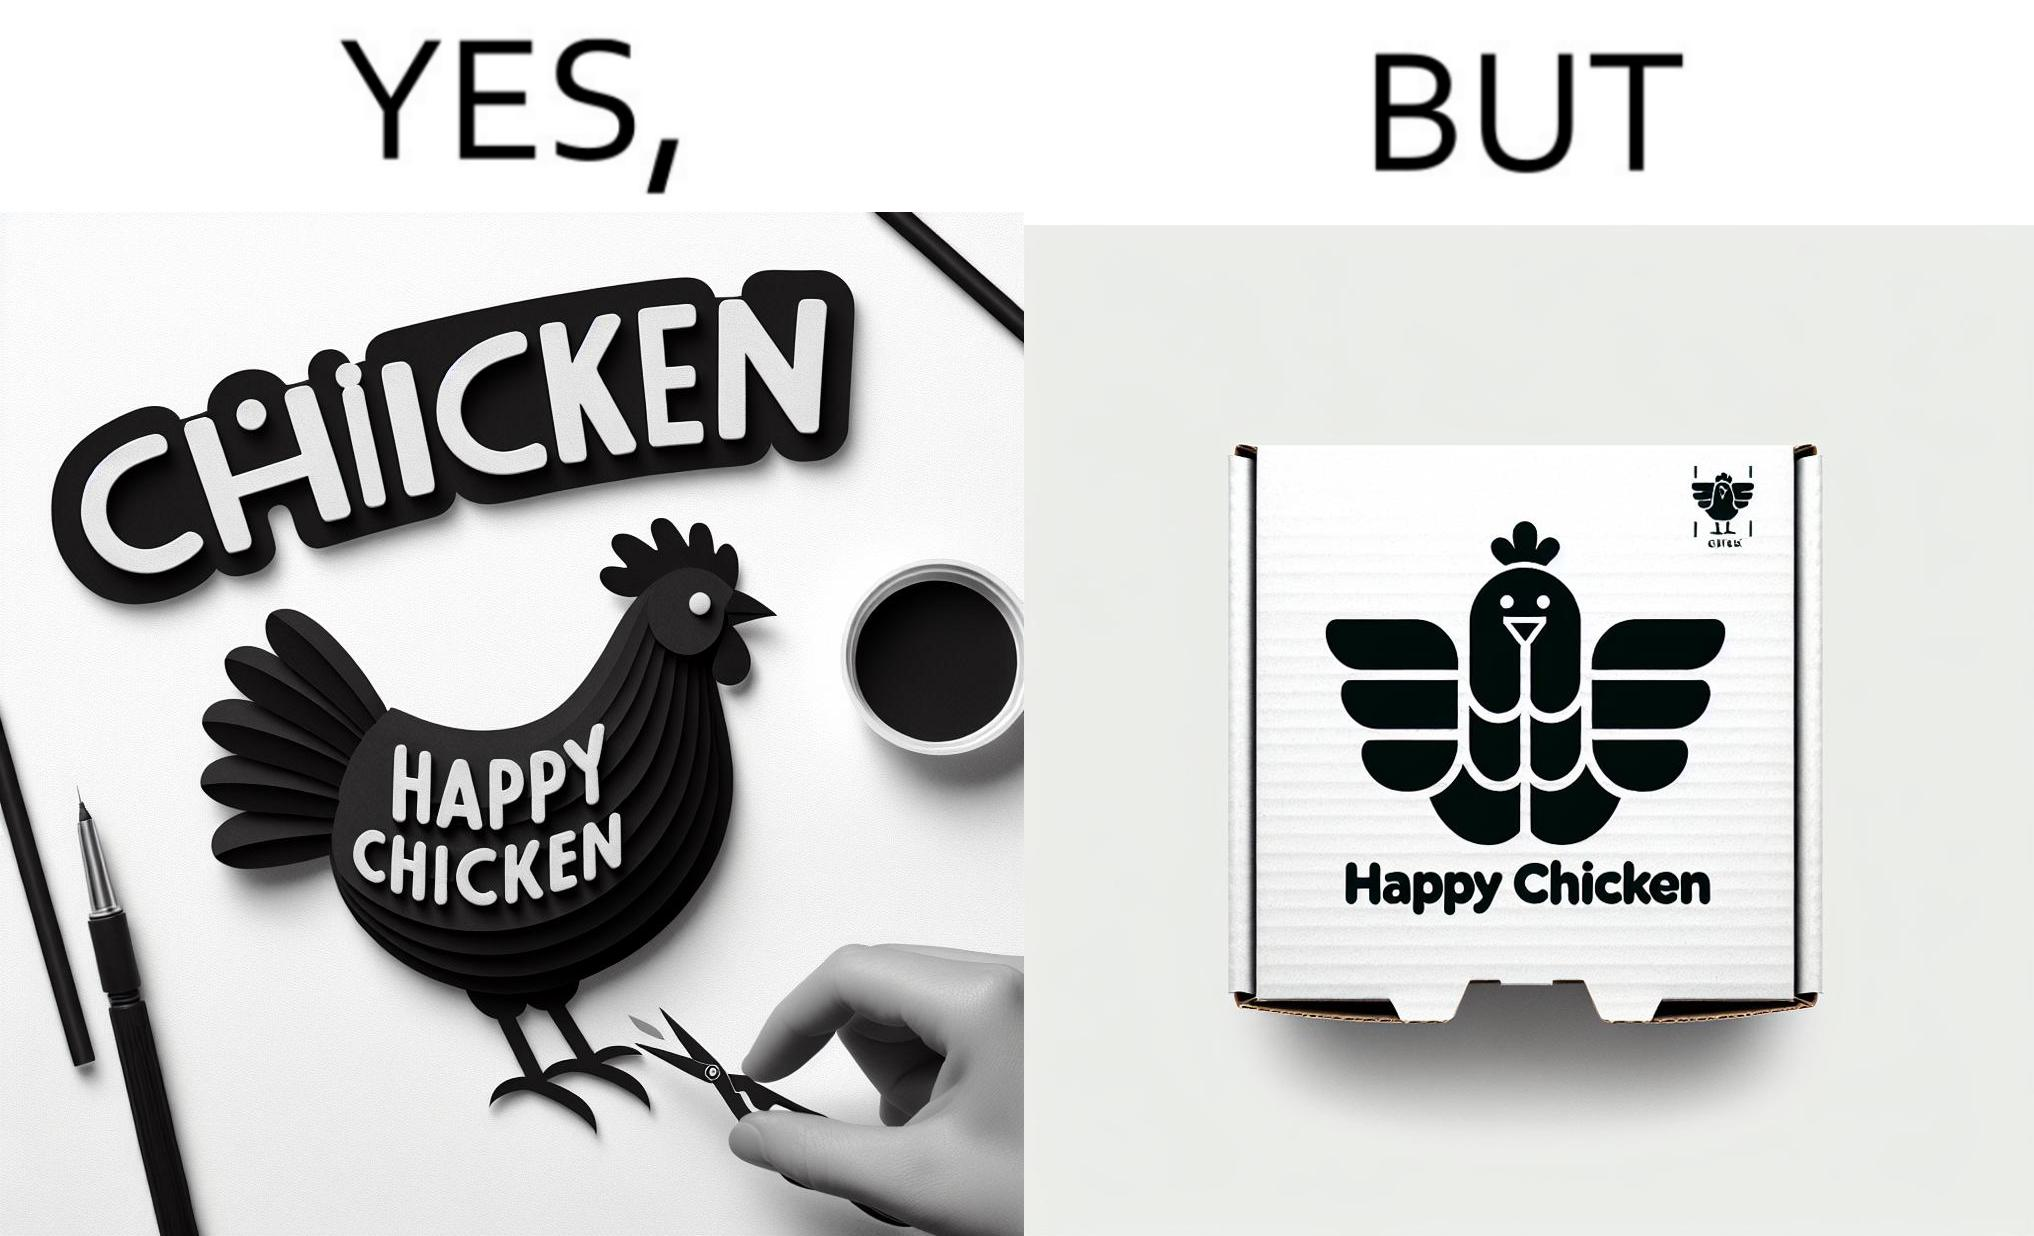Describe the content of this image. The image is ironic, because in the left image as in the logo it shows happy chicken but in the right image the chicken pieces are shown packed in boxes 